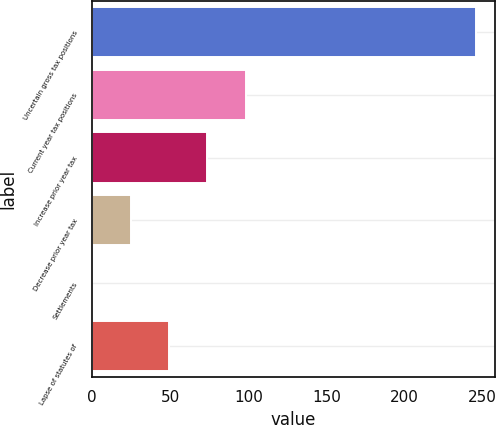<chart> <loc_0><loc_0><loc_500><loc_500><bar_chart><fcel>Uncertain gross tax positions<fcel>Current year tax positions<fcel>Increase prior year tax<fcel>Decrease prior year tax<fcel>Settlements<fcel>Lapse of statutes of<nl><fcel>245.5<fcel>98.38<fcel>73.86<fcel>24.82<fcel>0.3<fcel>49.34<nl></chart> 